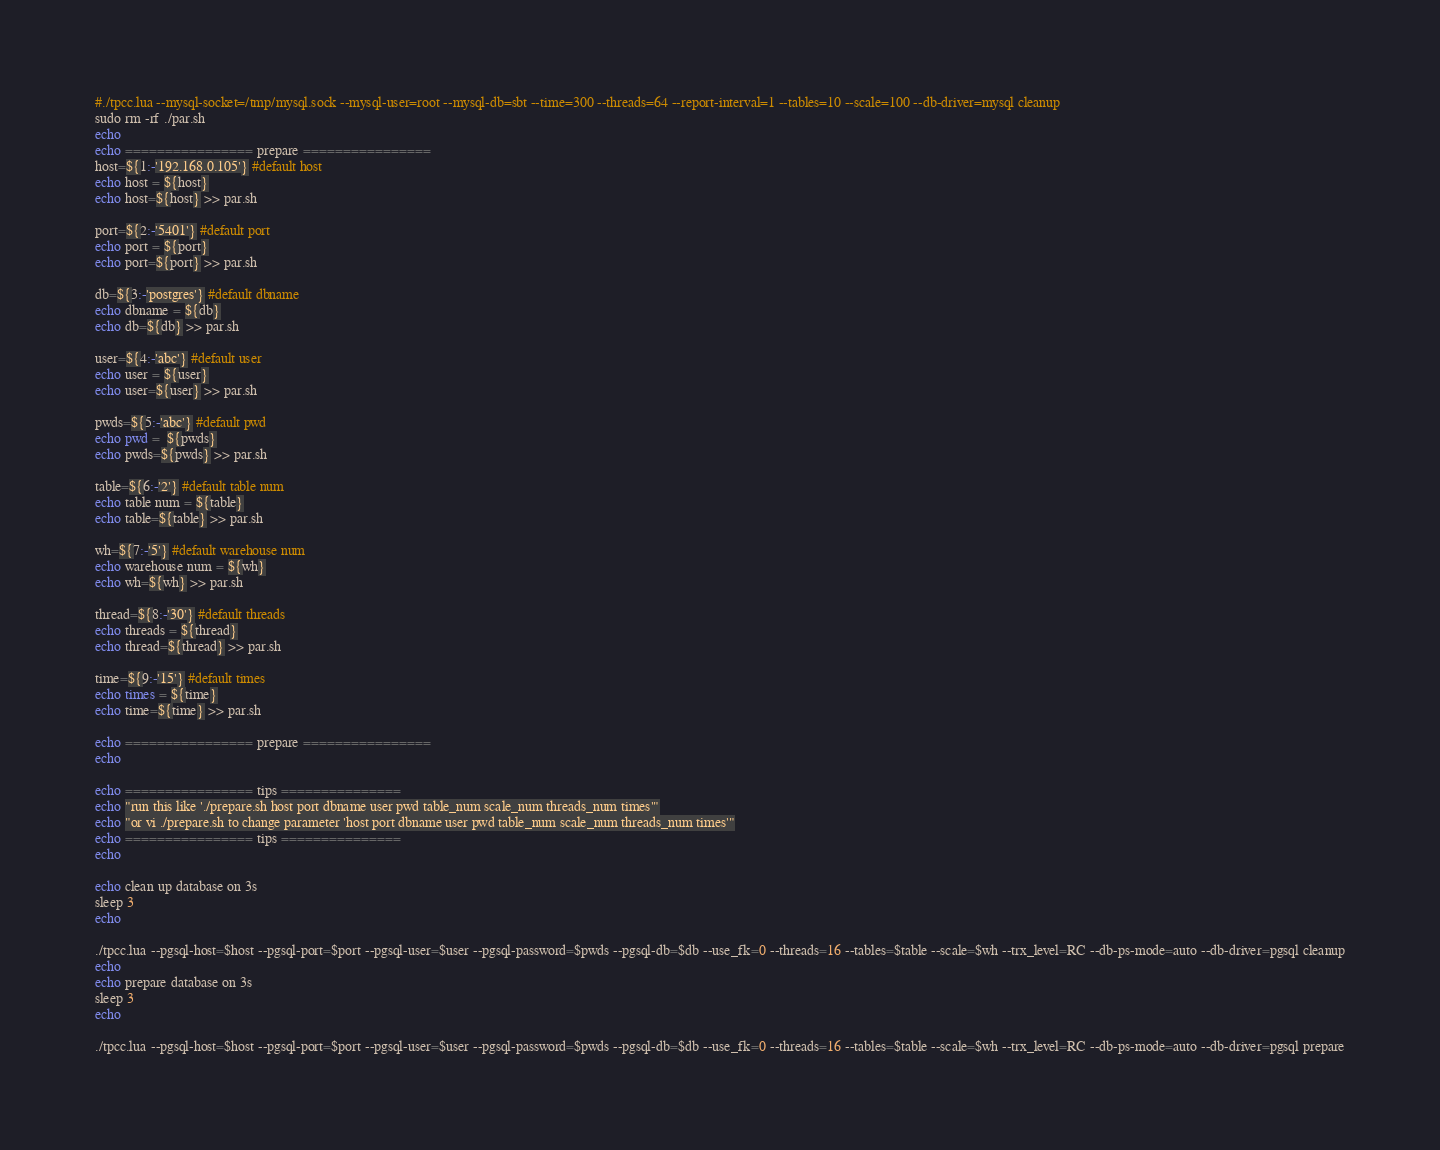<code> <loc_0><loc_0><loc_500><loc_500><_Bash_>#./tpcc.lua --mysql-socket=/tmp/mysql.sock --mysql-user=root --mysql-db=sbt --time=300 --threads=64 --report-interval=1 --tables=10 --scale=100 --db-driver=mysql cleanup
sudo rm -rf ./par.sh
echo
echo ================ prepare ================
host=${1:-'192.168.0.105'} #default host
echo host = ${host}
echo host=${host} >> par.sh

port=${2:-'5401'} #default port
echo port = ${port}
echo port=${port} >> par.sh

db=${3:-'postgres'} #default dbname
echo dbname = ${db}
echo db=${db} >> par.sh

user=${4:-'abc'} #default user
echo user = ${user}
echo user=${user} >> par.sh

pwds=${5:-'abc'} #default pwd
echo pwd =  ${pwds}
echo pwds=${pwds} >> par.sh

table=${6:-'2'} #default table num
echo table num = ${table}
echo table=${table} >> par.sh

wh=${7:-'5'} #default warehouse num
echo warehouse num = ${wh}
echo wh=${wh} >> par.sh

thread=${8:-'30'} #default threads
echo threads = ${thread}
echo thread=${thread} >> par.sh

time=${9:-'15'} #default times
echo times = ${time}
echo time=${time} >> par.sh

echo ================ prepare ================
echo

echo ================ tips ===============
echo "run this like './prepare.sh host port dbname user pwd table_num scale_num threads_num times'"
echo "or vi ./prepare.sh to change parameter 'host port dbname user pwd table_num scale_num threads_num times'"
echo ================ tips ===============
echo

echo clean up database on 3s
sleep 3
echo

./tpcc.lua --pgsql-host=$host --pgsql-port=$port --pgsql-user=$user --pgsql-password=$pwds --pgsql-db=$db --use_fk=0 --threads=16 --tables=$table --scale=$wh --trx_level=RC --db-ps-mode=auto --db-driver=pgsql cleanup
echo 
echo prepare database on 3s
sleep 3
echo

./tpcc.lua --pgsql-host=$host --pgsql-port=$port --pgsql-user=$user --pgsql-password=$pwds --pgsql-db=$db --use_fk=0 --threads=16 --tables=$table --scale=$wh --trx_level=RC --db-ps-mode=auto --db-driver=pgsql prepare
</code> 